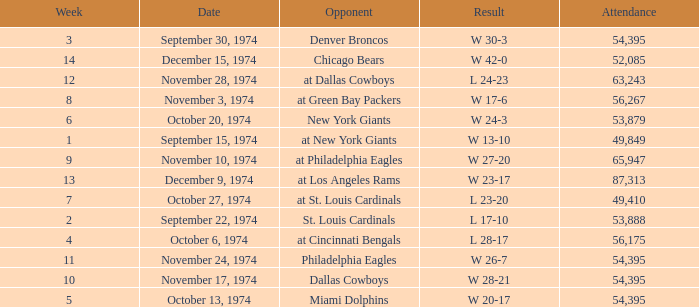What is the week of the game played on November 28, 1974? 12.0. 